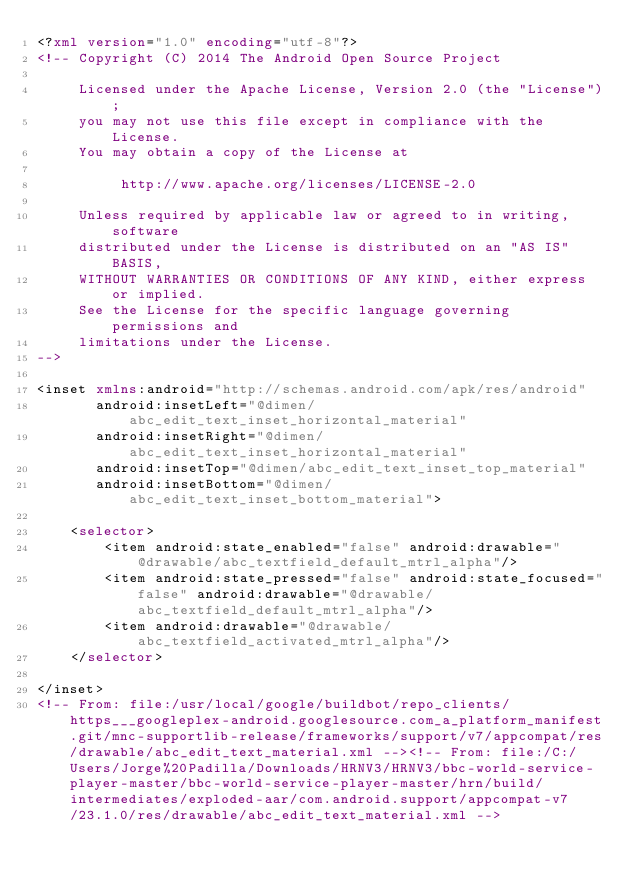<code> <loc_0><loc_0><loc_500><loc_500><_XML_><?xml version="1.0" encoding="utf-8"?>
<!-- Copyright (C) 2014 The Android Open Source Project

     Licensed under the Apache License, Version 2.0 (the "License");
     you may not use this file except in compliance with the License.
     You may obtain a copy of the License at

          http://www.apache.org/licenses/LICENSE-2.0

     Unless required by applicable law or agreed to in writing, software
     distributed under the License is distributed on an "AS IS" BASIS,
     WITHOUT WARRANTIES OR CONDITIONS OF ANY KIND, either express or implied.
     See the License for the specific language governing permissions and
     limitations under the License.
-->

<inset xmlns:android="http://schemas.android.com/apk/res/android"
       android:insetLeft="@dimen/abc_edit_text_inset_horizontal_material"
       android:insetRight="@dimen/abc_edit_text_inset_horizontal_material"
       android:insetTop="@dimen/abc_edit_text_inset_top_material"
       android:insetBottom="@dimen/abc_edit_text_inset_bottom_material">

    <selector>
        <item android:state_enabled="false" android:drawable="@drawable/abc_textfield_default_mtrl_alpha"/>
        <item android:state_pressed="false" android:state_focused="false" android:drawable="@drawable/abc_textfield_default_mtrl_alpha"/>
        <item android:drawable="@drawable/abc_textfield_activated_mtrl_alpha"/>
    </selector>

</inset>
<!-- From: file:/usr/local/google/buildbot/repo_clients/https___googleplex-android.googlesource.com_a_platform_manifest.git/mnc-supportlib-release/frameworks/support/v7/appcompat/res/drawable/abc_edit_text_material.xml --><!-- From: file:/C:/Users/Jorge%20Padilla/Downloads/HRNV3/HRNV3/bbc-world-service-player-master/bbc-world-service-player-master/hrn/build/intermediates/exploded-aar/com.android.support/appcompat-v7/23.1.0/res/drawable/abc_edit_text_material.xml --></code> 